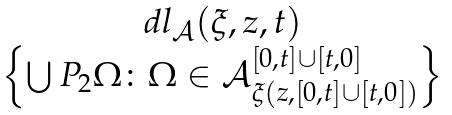<formula> <loc_0><loc_0><loc_500><loc_500>\begin{array} { c } d l _ { \mathcal { A } } ( \xi , z , t ) \\ \left \{ \bigcup P _ { 2 } \Omega \colon \Omega \in \mathcal { A } _ { \xi ( z , [ 0 , t ] \cup [ t , 0 ] ) } ^ { [ 0 , t ] \cup [ t , 0 ] } \right \} \\ \end{array}</formula> 